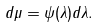<formula> <loc_0><loc_0><loc_500><loc_500>d \mu = \psi ( \lambda ) d \lambda .</formula> 